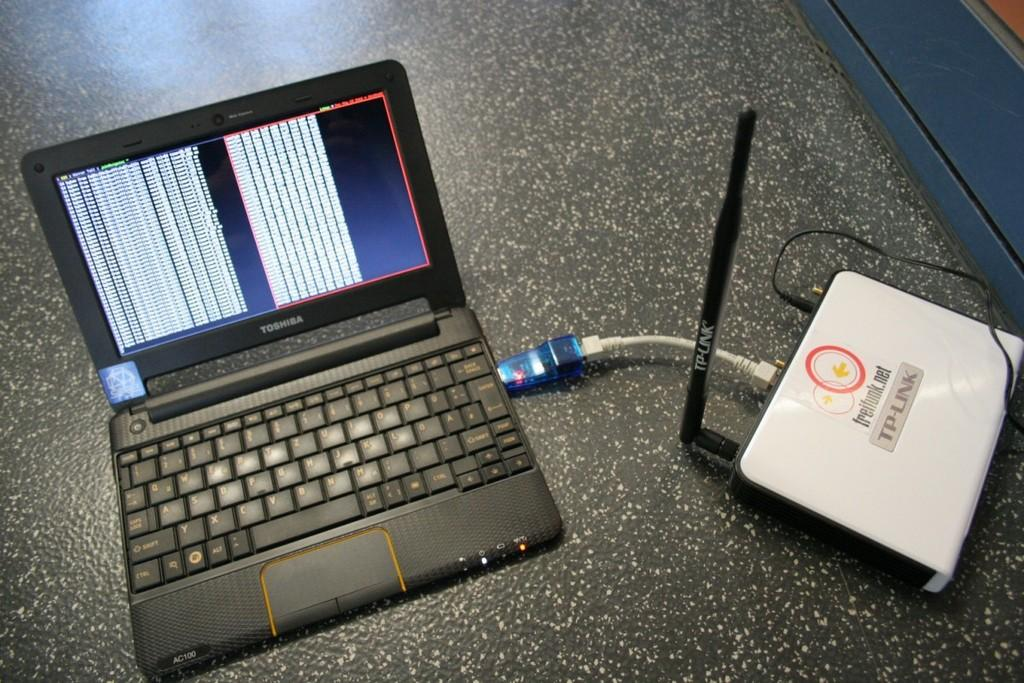<image>
Summarize the visual content of the image. Freifunk.net  TP Link reads the modem connected to the laptop. 